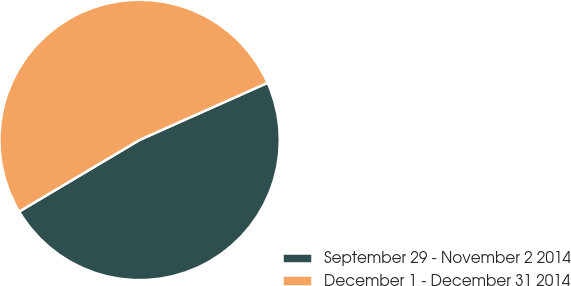<chart> <loc_0><loc_0><loc_500><loc_500><pie_chart><fcel>September 29 - November 2 2014<fcel>December 1 - December 31 2014<nl><fcel>48.14%<fcel>51.86%<nl></chart> 